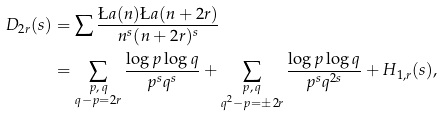<formula> <loc_0><loc_0><loc_500><loc_500>D _ { 2 r } ( s ) & = \sum \frac { \L a ( n ) \L a ( n + 2 r ) } { n ^ { s } ( n + 2 r ) ^ { s } } \\ & = \sum _ { \substack { p , \, q \\ q - p = 2 r } } \frac { \log p \log q } { p ^ { s } q ^ { s } } + \sum _ { \substack { p , \, q \\ q ^ { 2 } - p = \pm 2 r } } \frac { \log p \log q } { p ^ { s } q ^ { 2 s } } + H _ { 1 , r } ( s ) ,</formula> 